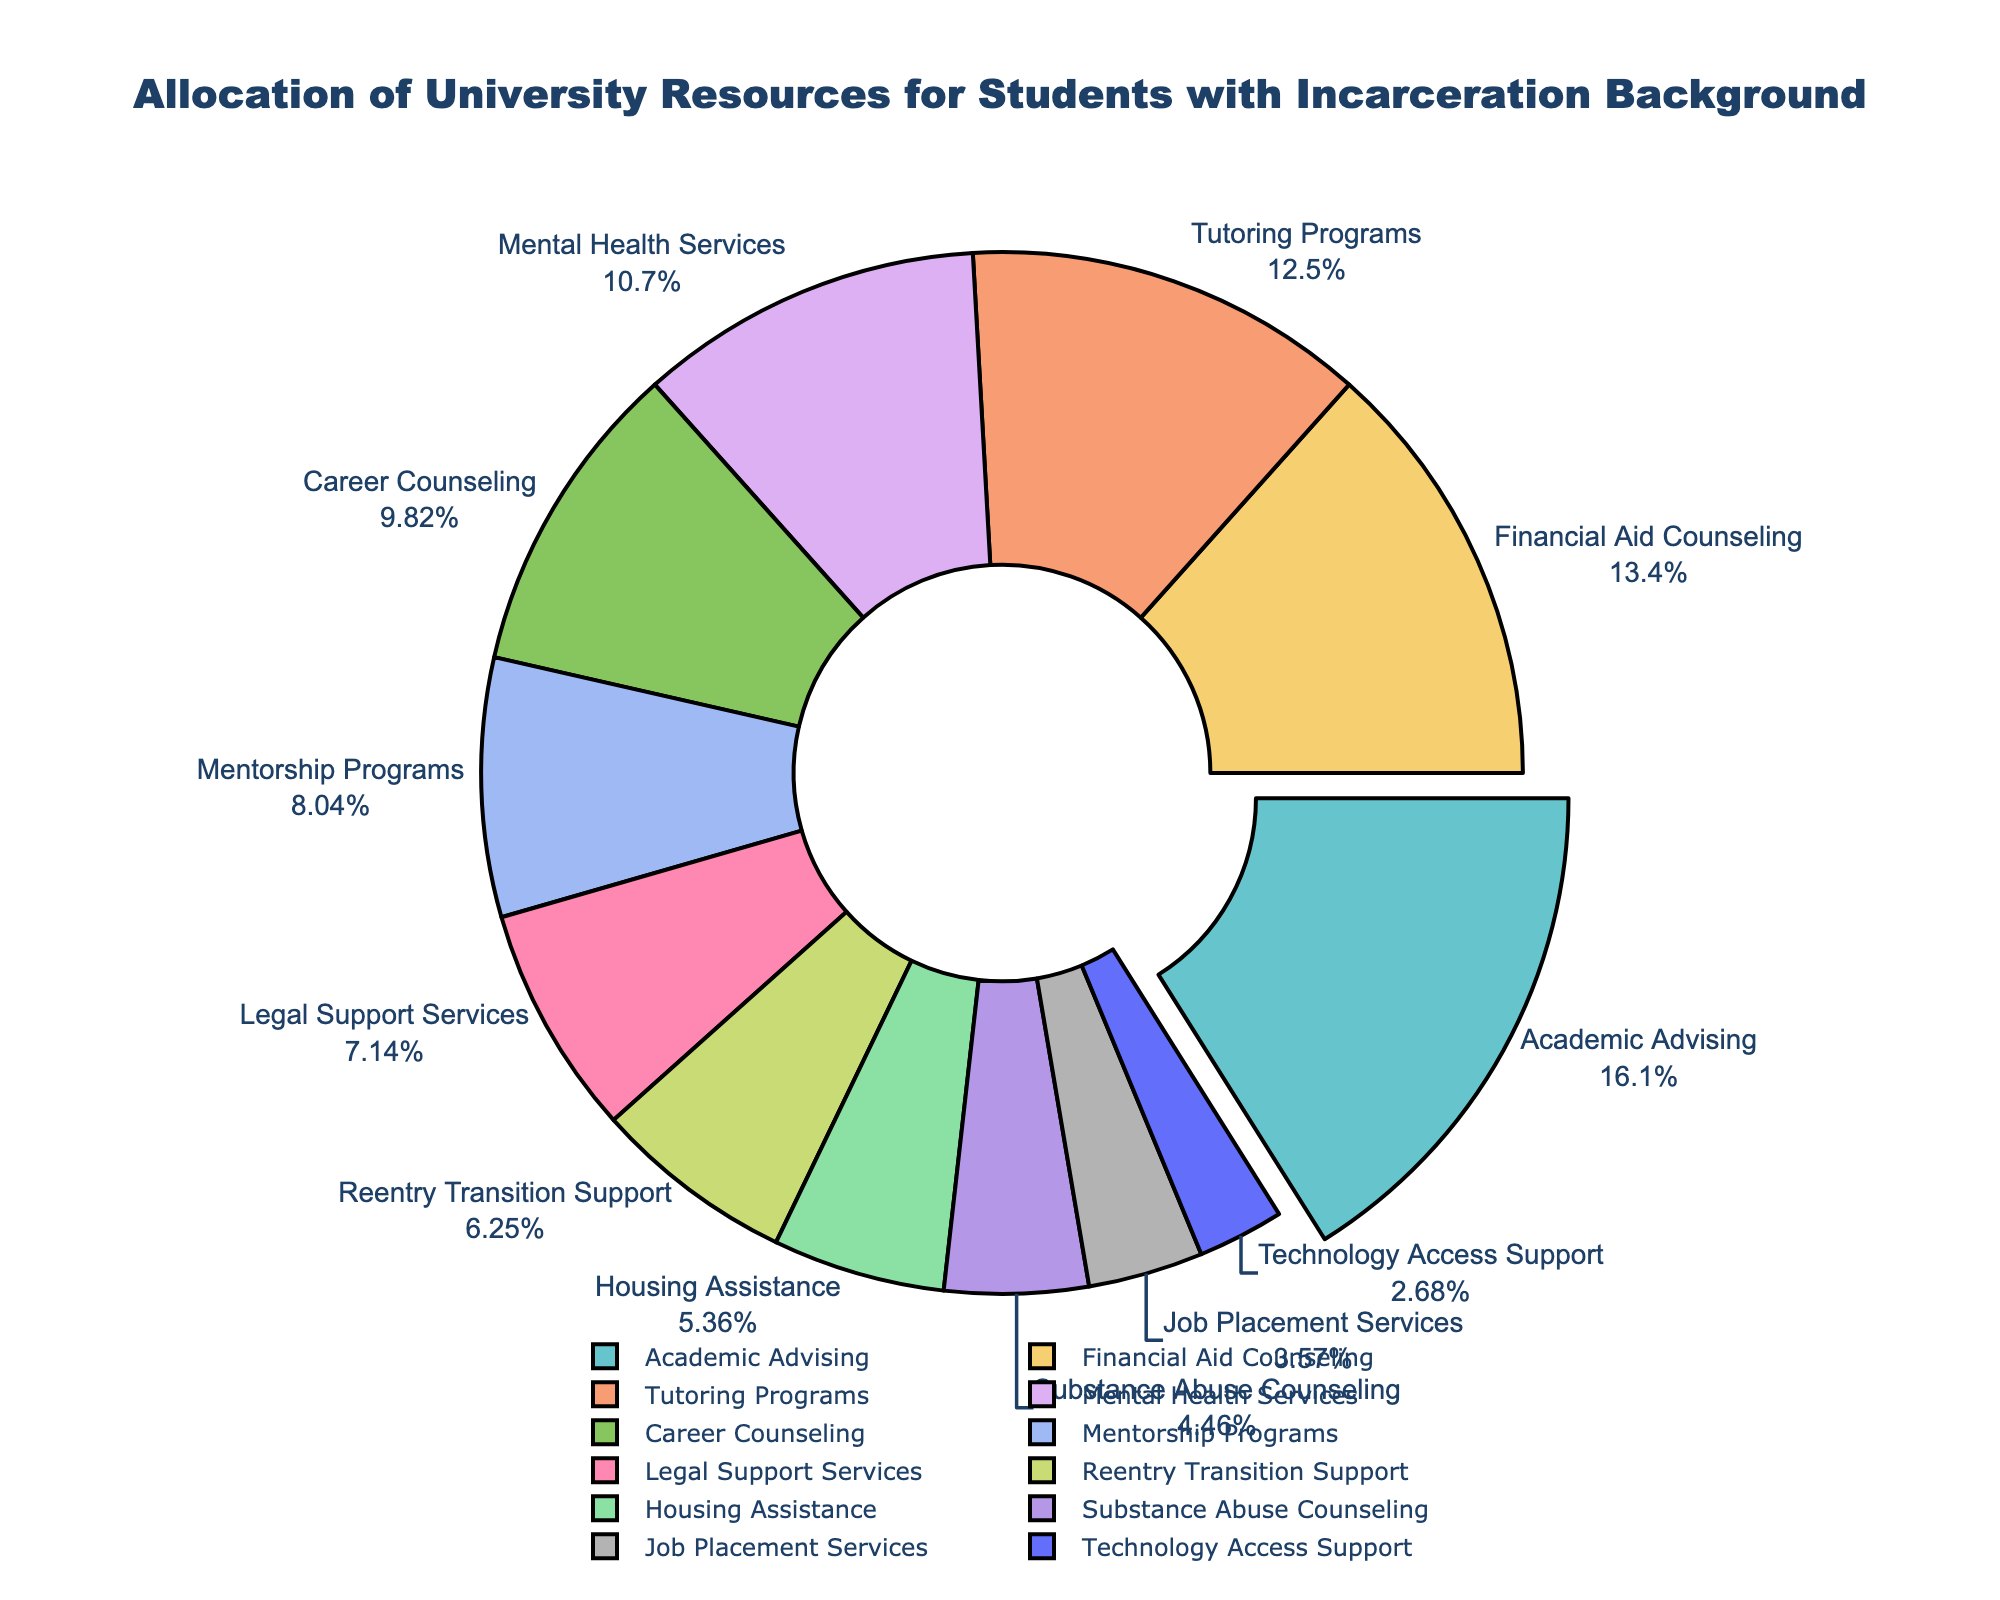Which two types of support services together account for 27% of the total resources? Adding the percentages of "Legal Support Services" (8%) and "Mentorship Programs" (9%) yields 17%, but adding "Reentry Transition Support" (7%) and "Housing Assistance" (6%) yields 13%. Combining "Career Counseling" (11%) and "Reentry Transition Support" (7%) yields 18%. Adding "Tutoring Programs" (14%) and "Career Counseling" (11%) results in 25%. Therefore, "Mentorship Programs" (9%) and "Reentry Transition Support" (7%) add up to 16%. The two that sum to 27% are "Mental Health Services" (12%) and "Tutoring Programs" (14%).
Answer: Mental Health Services and Tutoring Programs How much more percentage is allocated to Academic Advising than to Technology Access Support? Subtract the percentage for Technology Access Support (3%) from that of Academic Advising (18%). The difference is 18% - 3% = 15%.
Answer: 15% Which type of support service has the smallest allocation of university resources? The pie chart displays the smallest segment for the support service with the lowest percentage. Here, "Technology Access Support" is the smallest segment.
Answer: Technology Access Support What is the combined allocation for Career Counseling and Job Placement Services? Add the percentages allocated to Career Counseling (11%) and Job Placement Services (4%). The sum is 11% + 4% = 15%.
Answer: 15% Is the allocation for Financial Aid Counseling greater than that for Career Counseling? Compare the percentages of Financial Aid Counseling (15%) and Career Counseling (11%). Since 15% is greater than 11%, Financial Aid Counseling has higher allocation.
Answer: Yes What is the total percentage allocated to Legal Support Services and Housing Assistance? Add the percentages for Legal Support Services (8%) and Housing Assistance (6%). The total is 8% + 6% = 14%.
Answer: 14% Which segment of support services appears to be visually the largest on the chart? The segment with the largest visible area and labeled percentage is for "Academic Advising", indicating it covers the most space on the pie chart.
Answer: Academic Advising Are there more resources allocated to Mental Health Services or to Tutoring Programs? By how much? Compare the percentages for Mental Health Services (12%) and for Tutoring Programs (14%). Tutoring Programs has a 2% higher allocation than Mental Health Services.
Answer: Tutoring Programs by 2% 